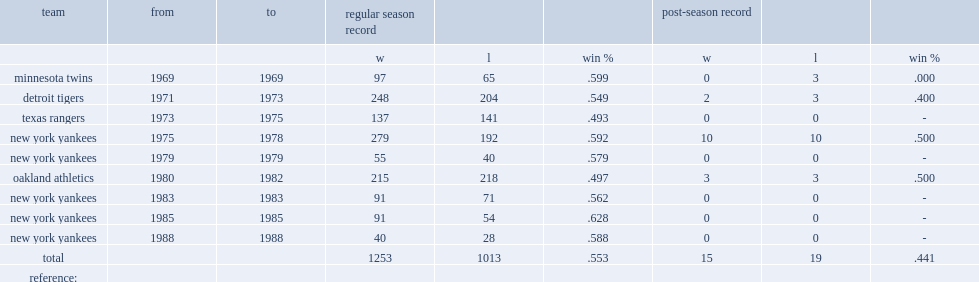From 1980 to 1982, which team did billy martin play for? Oakland athletics. 